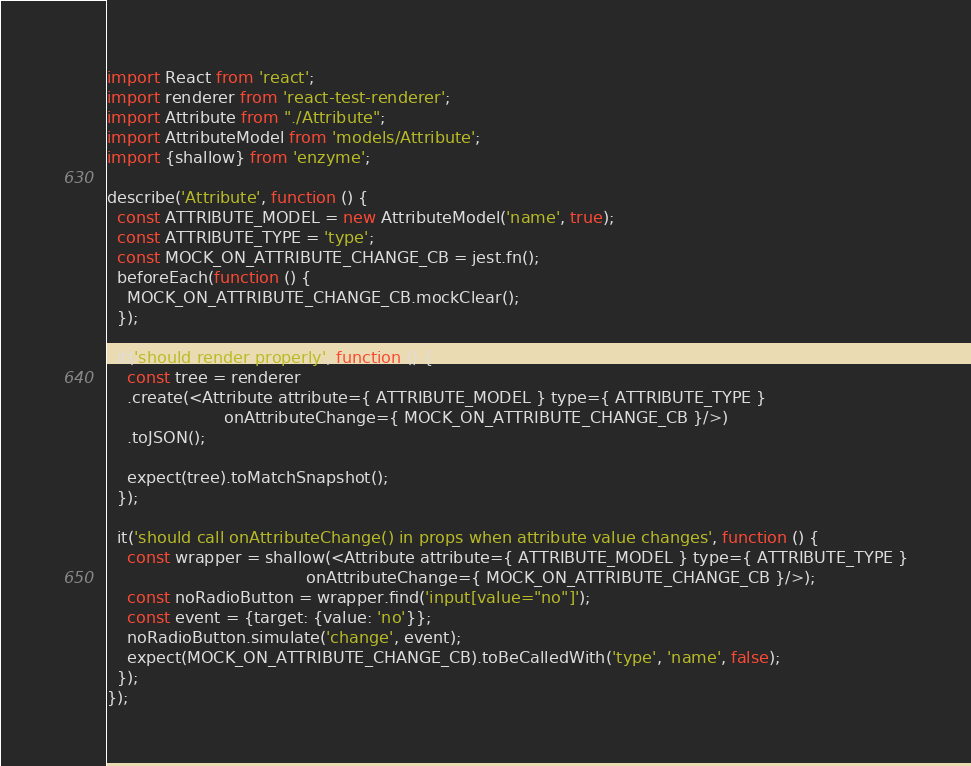<code> <loc_0><loc_0><loc_500><loc_500><_JavaScript_>import React from 'react';
import renderer from 'react-test-renderer';
import Attribute from "./Attribute";
import AttributeModel from 'models/Attribute';
import {shallow} from 'enzyme';

describe('Attribute', function () {
  const ATTRIBUTE_MODEL = new AttributeModel('name', true);
  const ATTRIBUTE_TYPE = 'type';
  const MOCK_ON_ATTRIBUTE_CHANGE_CB = jest.fn();
  beforeEach(function () {
    MOCK_ON_ATTRIBUTE_CHANGE_CB.mockClear();
  });

  it('should render properly', function () {
    const tree = renderer
    .create(<Attribute attribute={ ATTRIBUTE_MODEL } type={ ATTRIBUTE_TYPE }
                       onAttributeChange={ MOCK_ON_ATTRIBUTE_CHANGE_CB }/>)
    .toJSON();

    expect(tree).toMatchSnapshot();
  });

  it('should call onAttributeChange() in props when attribute value changes', function () {
    const wrapper = shallow(<Attribute attribute={ ATTRIBUTE_MODEL } type={ ATTRIBUTE_TYPE }
                                       onAttributeChange={ MOCK_ON_ATTRIBUTE_CHANGE_CB }/>);
    const noRadioButton = wrapper.find('input[value="no"]');
    const event = {target: {value: 'no'}};
    noRadioButton.simulate('change', event);
    expect(MOCK_ON_ATTRIBUTE_CHANGE_CB).toBeCalledWith('type', 'name', false);
  });
});</code> 